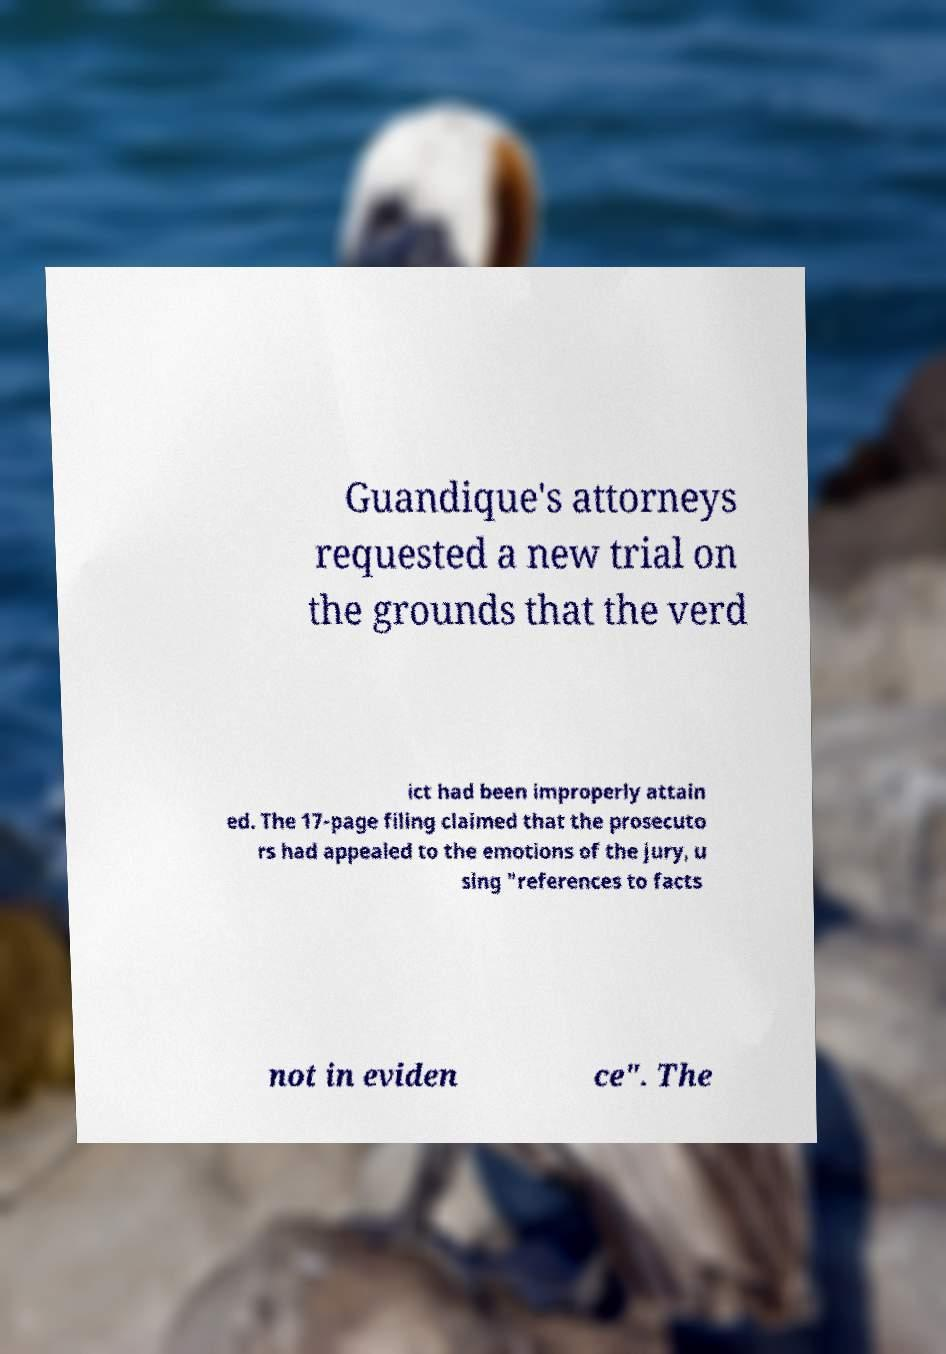Could you extract and type out the text from this image? Guandique's attorneys requested a new trial on the grounds that the verd ict had been improperly attain ed. The 17-page filing claimed that the prosecuto rs had appealed to the emotions of the jury, u sing "references to facts not in eviden ce". The 